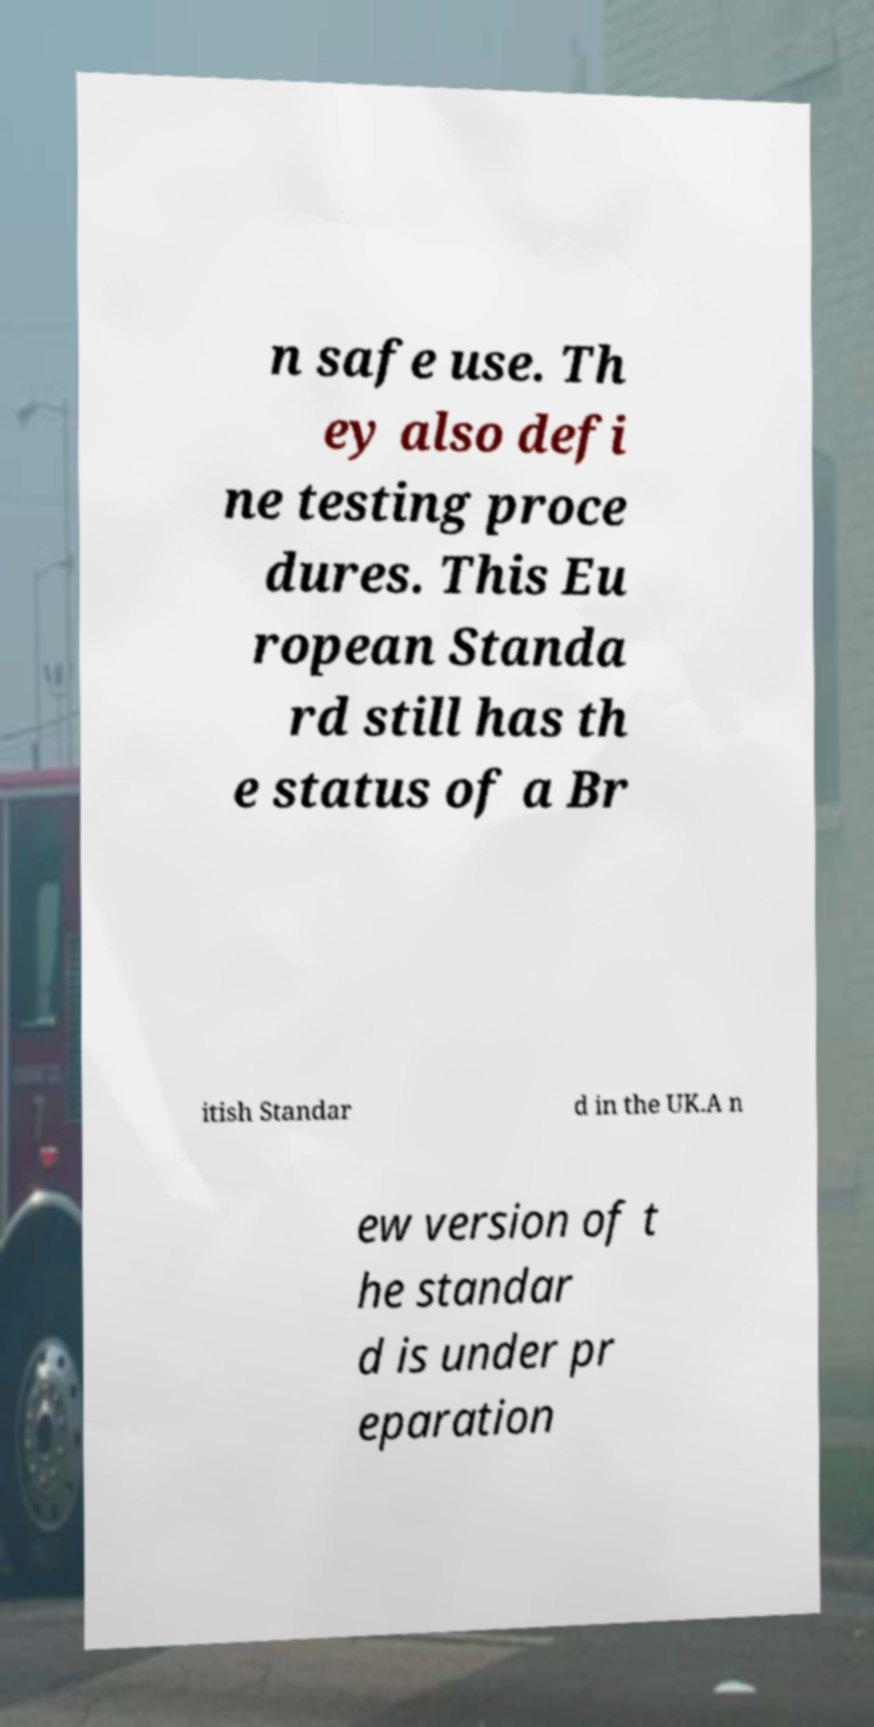There's text embedded in this image that I need extracted. Can you transcribe it verbatim? n safe use. Th ey also defi ne testing proce dures. This Eu ropean Standa rd still has th e status of a Br itish Standar d in the UK.A n ew version of t he standar d is under pr eparation 